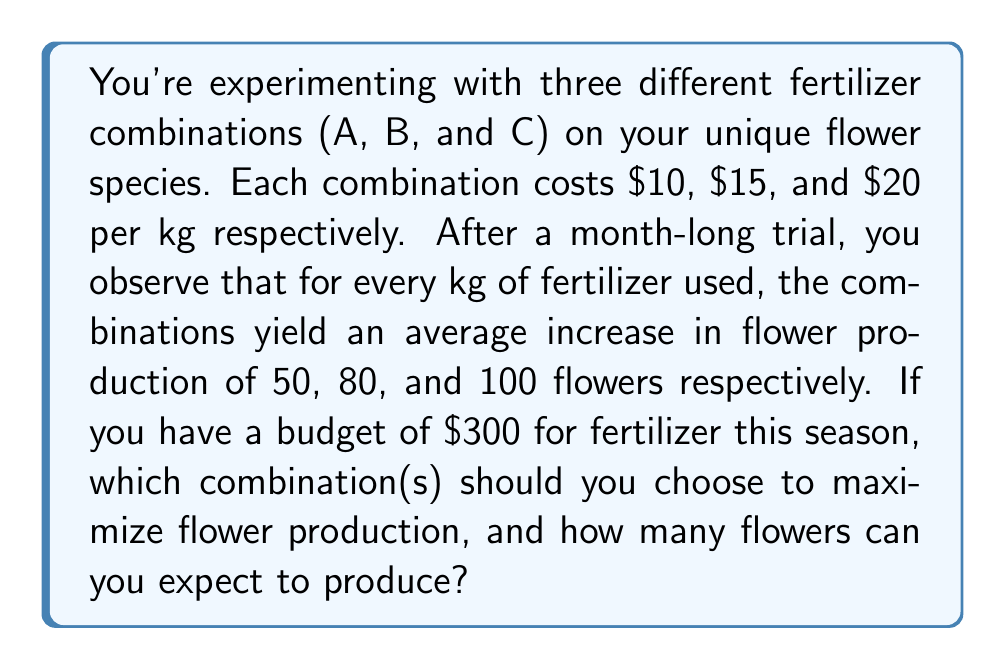Provide a solution to this math problem. Let's approach this step-by-step:

1) First, we need to calculate the cost-effectiveness of each fertilizer combination. This can be done by dividing the number of flowers produced per kg by the cost per kg:

   Combination A: $\frac{50 \text{ flowers}}{\$10} = 5 \text{ flowers}/\$$
   Combination B: $\frac{80 \text{ flowers}}{\$15} \approx 5.33 \text{ flowers}/\$$
   Combination C: $\frac{100 \text{ flowers}}{\$20} = 5 \text{ flowers}/\$$

2) Combination B is the most cost-effective, producing about 5.33 flowers per dollar spent.

3) To maximize flower production, we should use all of the budget on Combination B.

4) To calculate how many kg of Combination B we can buy:

   $\frac{\$300}{\$15/\text{kg}} = 20 \text{ kg}$

5) Now, we can calculate the total number of flowers produced:

   $20 \text{ kg} \times 80 \text{ flowers/kg} = 1600 \text{ flowers}$

Therefore, by using all $\$300$ on Combination B, you can maximize your flower production.
Answer: You should choose Combination B, which will produce an expected 1600 flowers with a $\$300$ budget. 